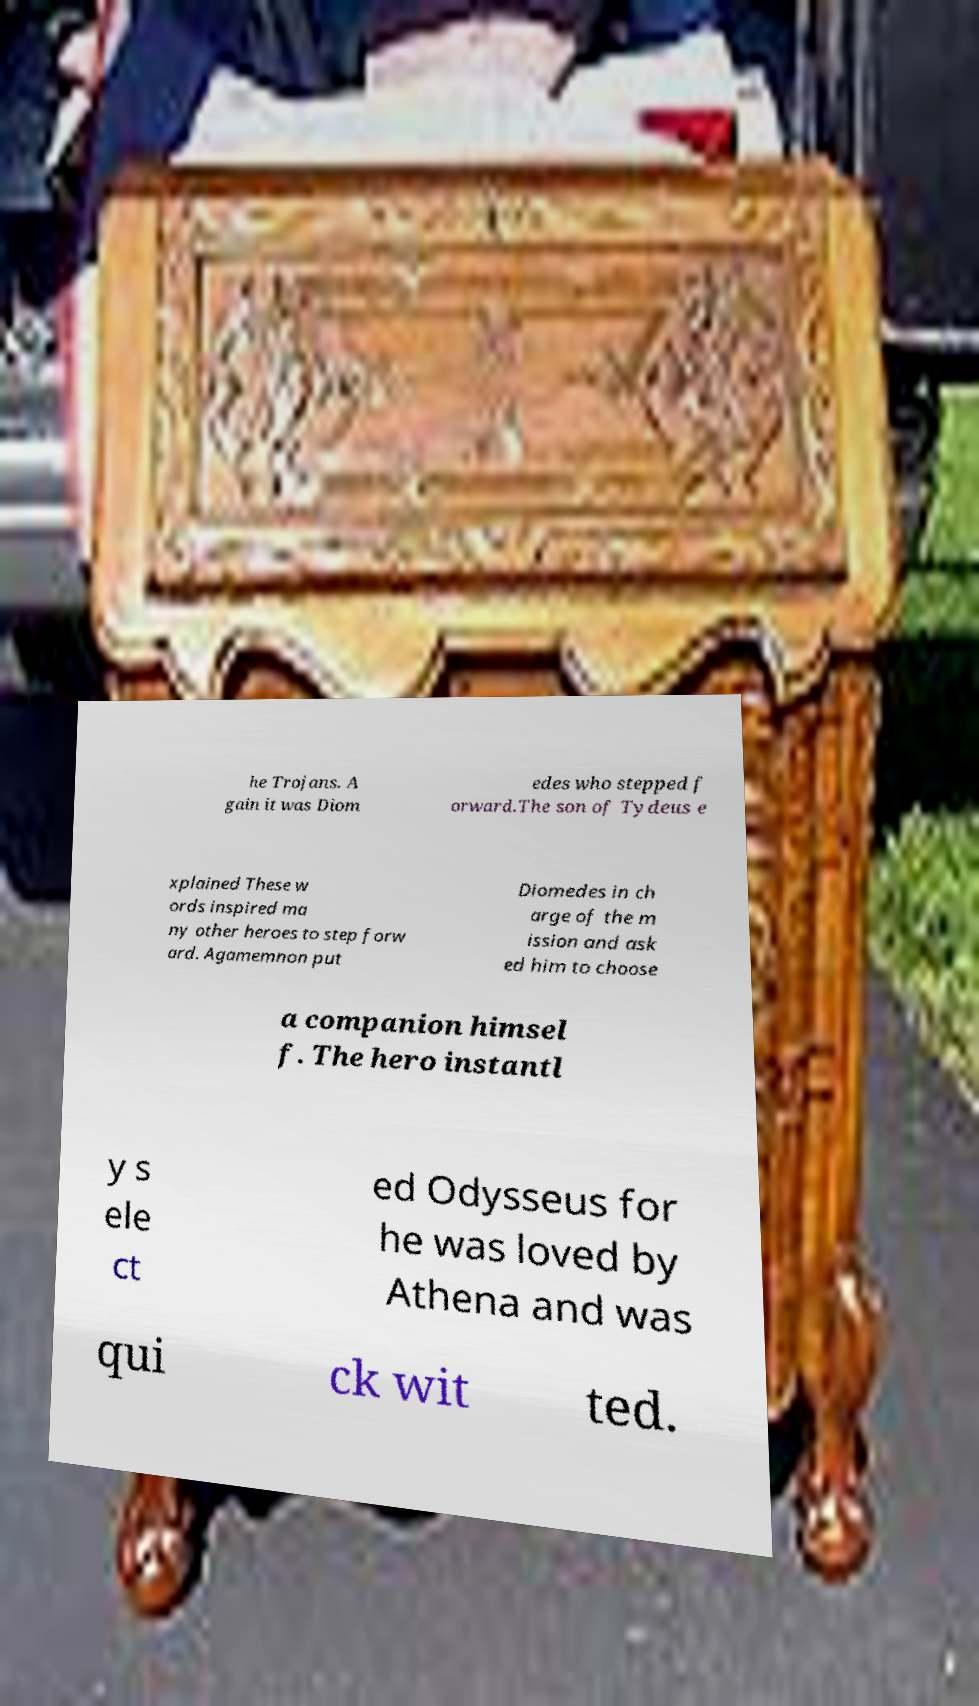Could you assist in decoding the text presented in this image and type it out clearly? he Trojans. A gain it was Diom edes who stepped f orward.The son of Tydeus e xplained These w ords inspired ma ny other heroes to step forw ard. Agamemnon put Diomedes in ch arge of the m ission and ask ed him to choose a companion himsel f. The hero instantl y s ele ct ed Odysseus for he was loved by Athena and was qui ck wit ted. 